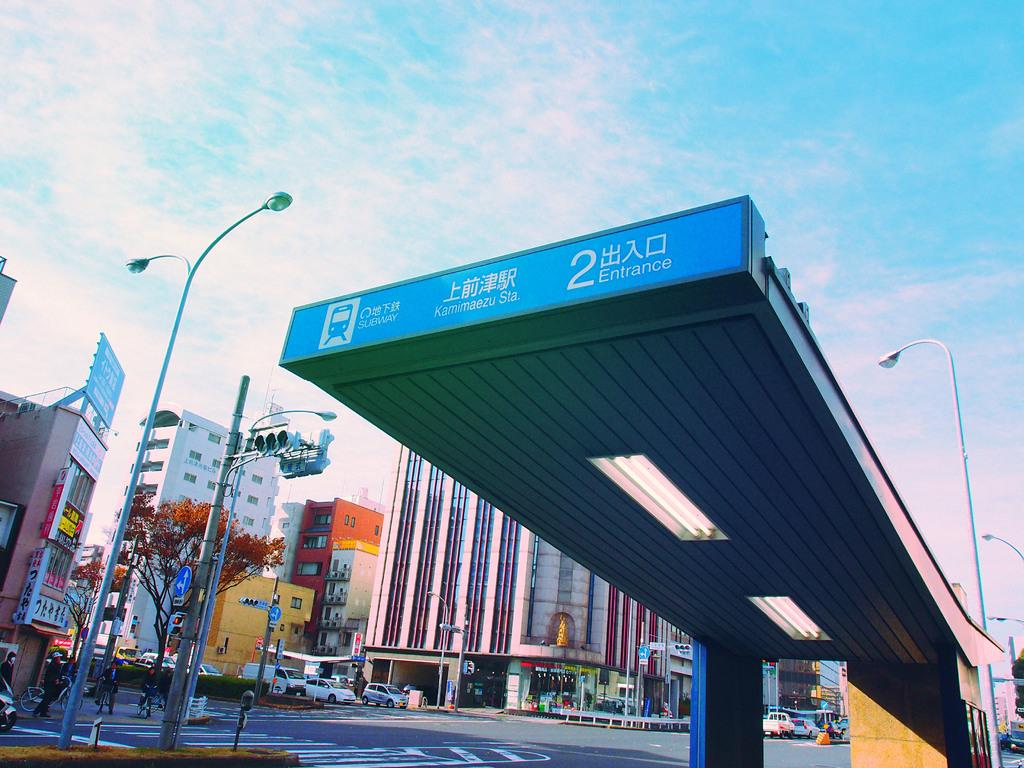What type of structures can be seen in the image? There are buildings in the image. What natural element is present in the image? There is a tree in the image. What type of lighting is visible in the image? There are pole lights and a pole with traffic signal lights in the image. What type of transportation can be seen in the image? There are vehicles on the road in the image. How would you describe the sky in the image? The sky is blue and cloudy in the image. Can you see any cherries hanging from the tree in the image? There are no cherries present in the image; the tree is not specified as a fruit tree. What type of yarn is being used to create the traffic signal lights in the image? The traffic signal lights in the image are not made of yarn; they are electronic devices. 